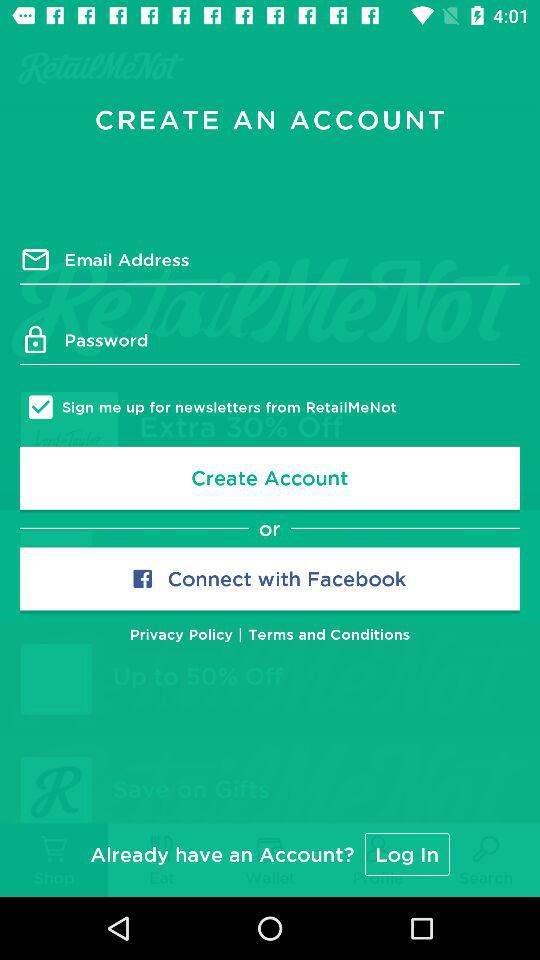What is the status of "Sign me up for newsletters from RetailMeNot"? The status is "on". 